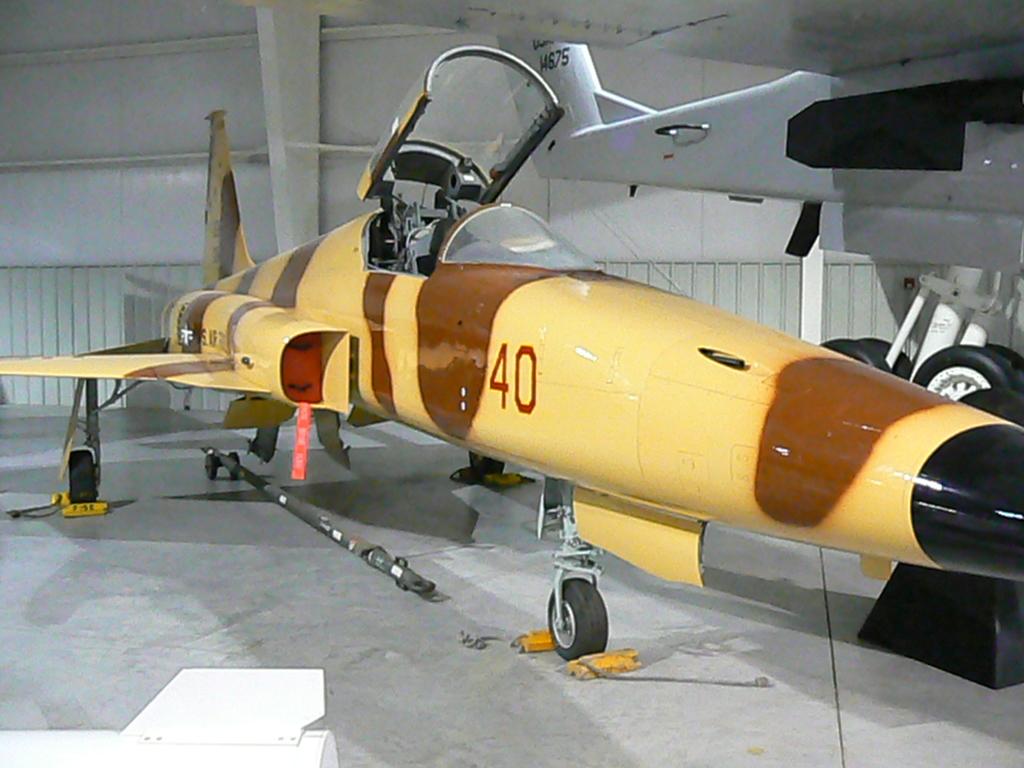What number is on the plane?
Your response must be concise. 40. What letter/number code is on the tail of the white plane?
Your answer should be compact. 40. 